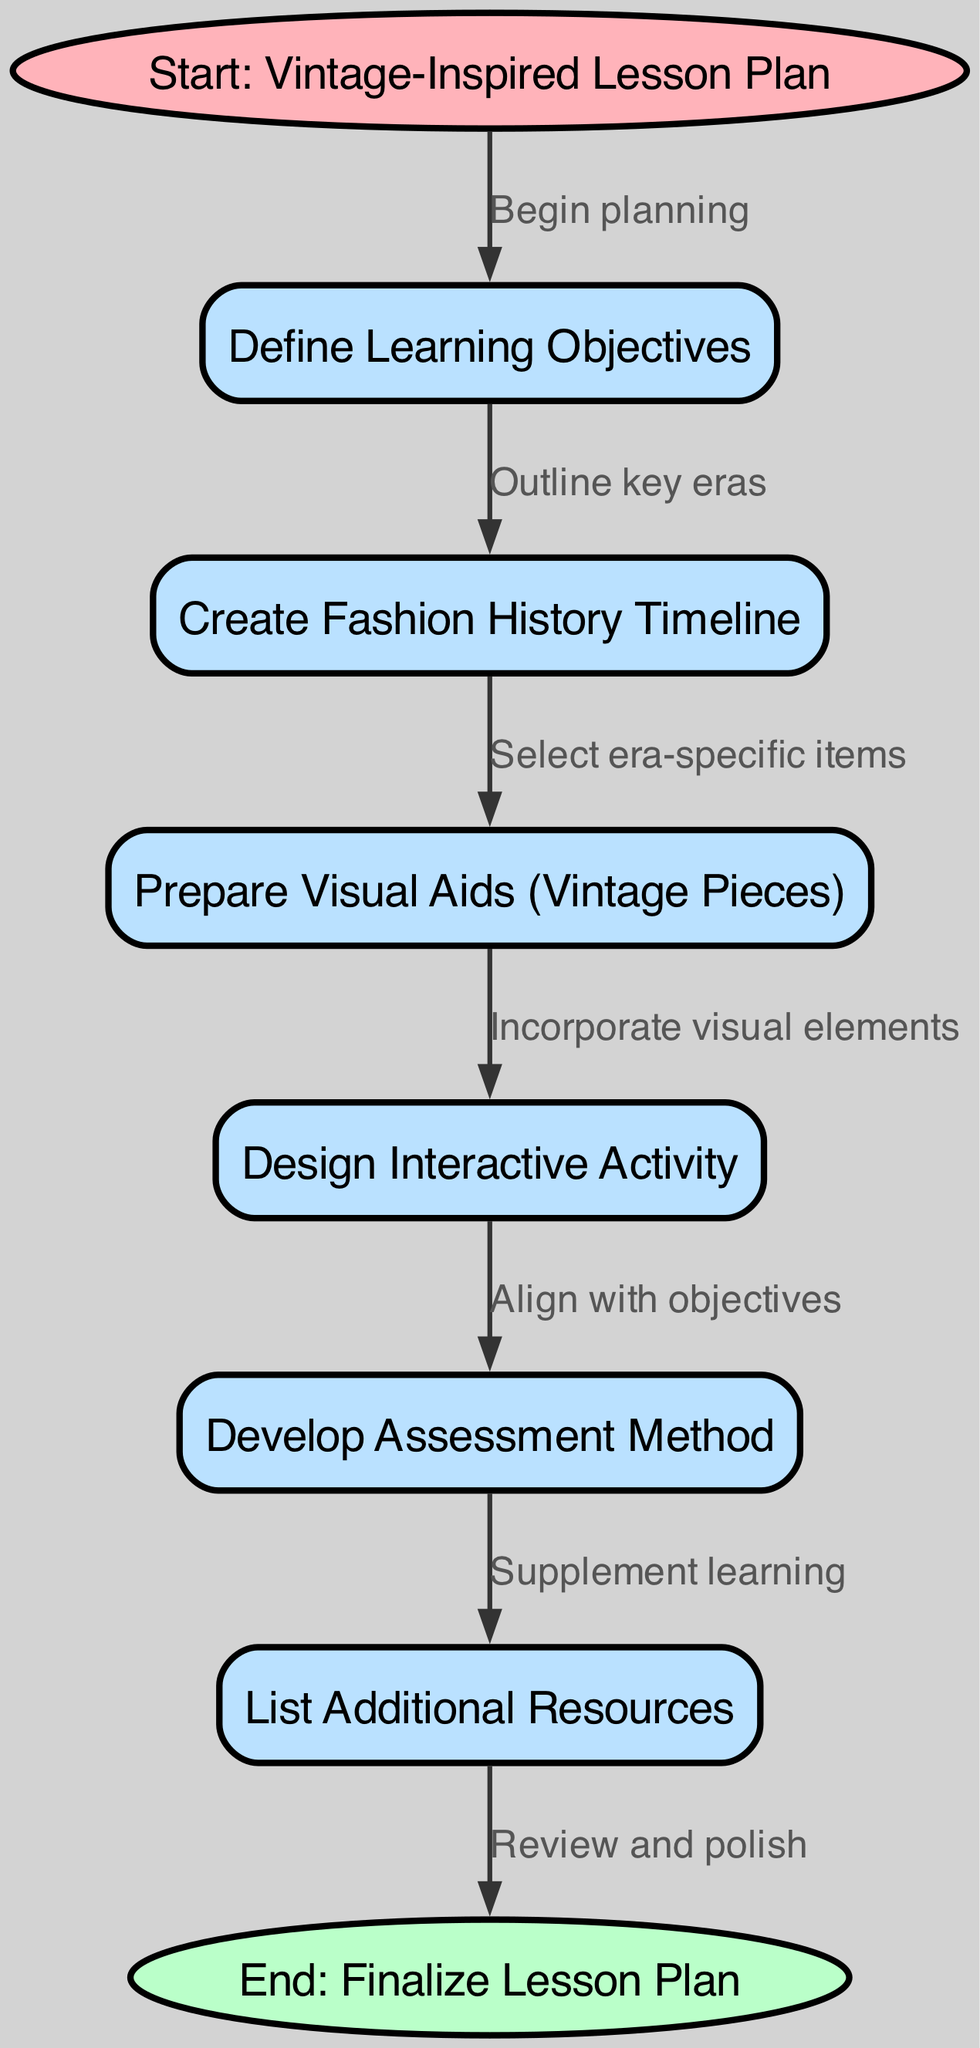What is the first step in the lesson plan? The first step in the lesson plan is labeled as "Start: Vintage-Inspired Lesson Plan", which indicates the beginning of the process.
Answer: Start: Vintage-Inspired Lesson Plan How many nodes are present in the diagram? The diagram includes 8 distinct nodes, each representing a step in the lesson planning process. Counting them gives a total of eight.
Answer: 8 What is the last step mentioned in the diagram? The last step is labeled "End: Finalize Lesson Plan", indicating the completion of the process of creating the lesson plan.
Answer: End: Finalize Lesson Plan Which node follows the “Prepare Visual Aids (Vintage Pieces)” node? The node that follows "Prepare Visual Aids (Vintage Pieces)" is "Design Interactive Activity", as it is directly connected in the flowchart.
Answer: Design Interactive Activity What does the “Design Interactive Activity” node align with? The "Design Interactive Activity" node aligns with the "Develop Assessment Method" as it follows logically in the flowchart, ensuring it meets the learning objectives set at the beginning.
Answer: Develop Assessment Method What is the relationship between “Define Learning Objectives” and “Create Fashion History Timeline”? The relationship is that "Define Learning Objectives" precedes "Create Fashion History Timeline", indicating that defining objectives is necessary before outlining historical eras.
Answer: Outline key eras List the resources mentioned as a part of the lesson plan process. The resources mentioned in the process are stated in the "List Additional Resources" node, which is part of the final steps following assessment development.
Answer: List Additional Resources What visual elements are incorporated before the interactive activity? The visual elements referred to are "Prepare Visual Aids (Vintage Pieces)", which are necessary to engage students during the interactive activity.
Answer: Prepare Visual Aids (Vintage Pieces) 